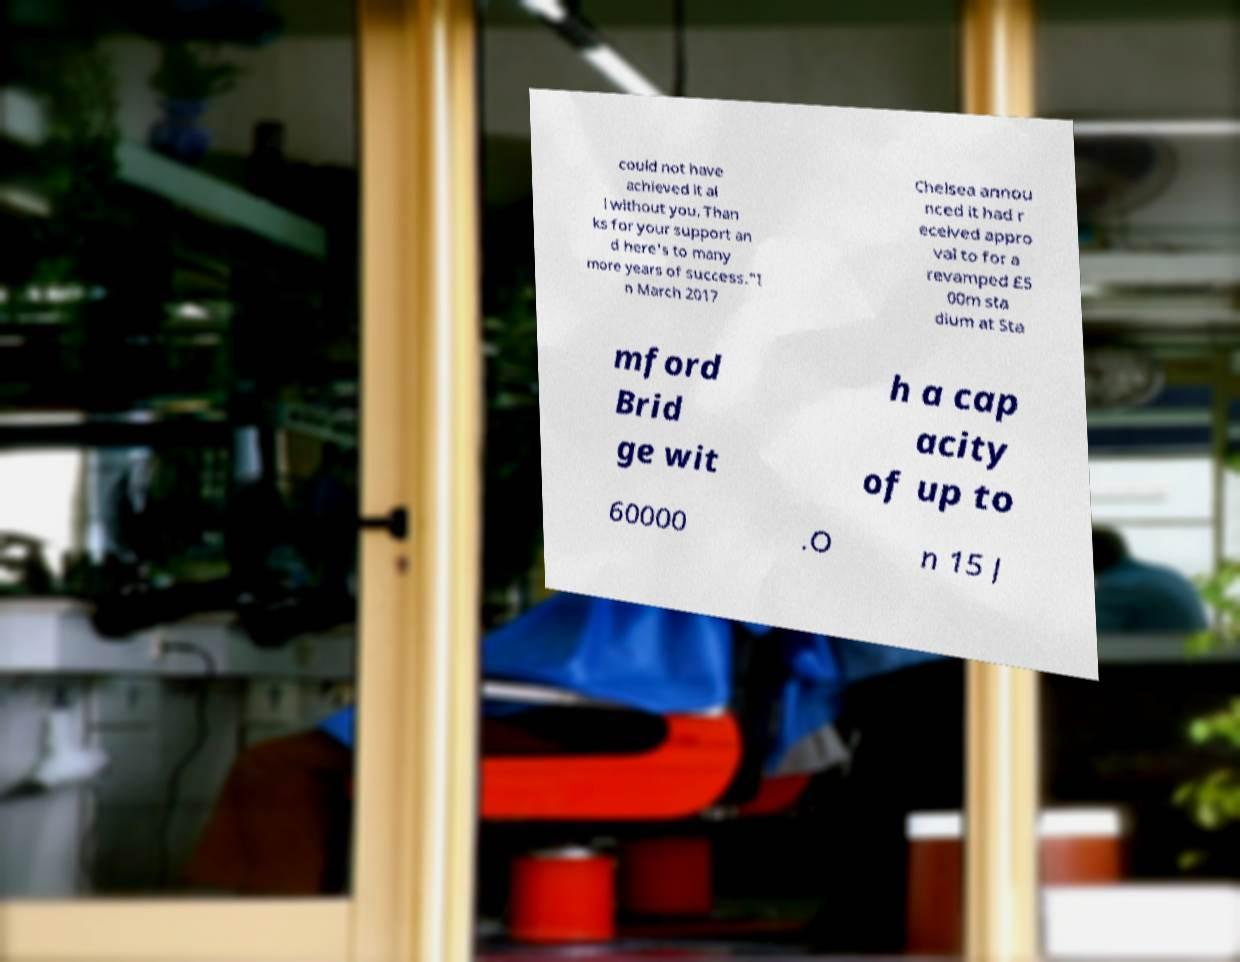Could you extract and type out the text from this image? could not have achieved it al l without you. Than ks for your support an d here's to many more years of success."I n March 2017 Chelsea annou nced it had r eceived appro val to for a revamped £5 00m sta dium at Sta mford Brid ge wit h a cap acity of up to 60000 .O n 15 J 